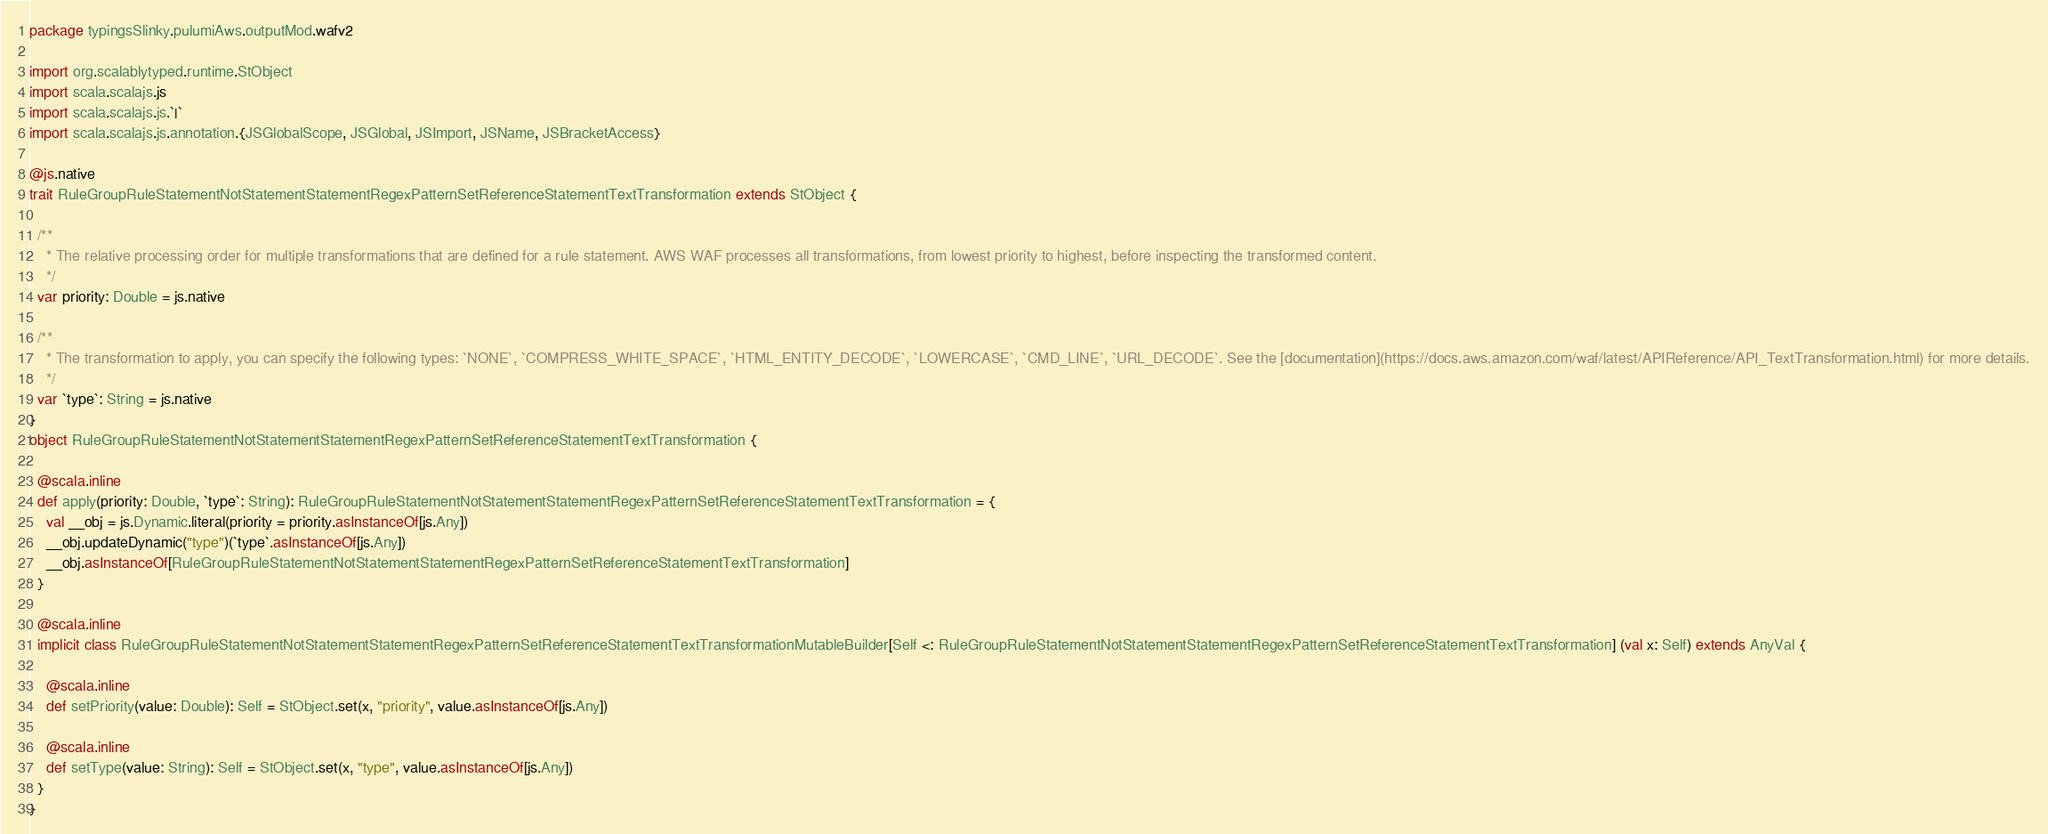Convert code to text. <code><loc_0><loc_0><loc_500><loc_500><_Scala_>package typingsSlinky.pulumiAws.outputMod.wafv2

import org.scalablytyped.runtime.StObject
import scala.scalajs.js
import scala.scalajs.js.`|`
import scala.scalajs.js.annotation.{JSGlobalScope, JSGlobal, JSImport, JSName, JSBracketAccess}

@js.native
trait RuleGroupRuleStatementNotStatementStatementRegexPatternSetReferenceStatementTextTransformation extends StObject {
  
  /**
    * The relative processing order for multiple transformations that are defined for a rule statement. AWS WAF processes all transformations, from lowest priority to highest, before inspecting the transformed content.
    */
  var priority: Double = js.native
  
  /**
    * The transformation to apply, you can specify the following types: `NONE`, `COMPRESS_WHITE_SPACE`, `HTML_ENTITY_DECODE`, `LOWERCASE`, `CMD_LINE`, `URL_DECODE`. See the [documentation](https://docs.aws.amazon.com/waf/latest/APIReference/API_TextTransformation.html) for more details.
    */
  var `type`: String = js.native
}
object RuleGroupRuleStatementNotStatementStatementRegexPatternSetReferenceStatementTextTransformation {
  
  @scala.inline
  def apply(priority: Double, `type`: String): RuleGroupRuleStatementNotStatementStatementRegexPatternSetReferenceStatementTextTransformation = {
    val __obj = js.Dynamic.literal(priority = priority.asInstanceOf[js.Any])
    __obj.updateDynamic("type")(`type`.asInstanceOf[js.Any])
    __obj.asInstanceOf[RuleGroupRuleStatementNotStatementStatementRegexPatternSetReferenceStatementTextTransformation]
  }
  
  @scala.inline
  implicit class RuleGroupRuleStatementNotStatementStatementRegexPatternSetReferenceStatementTextTransformationMutableBuilder[Self <: RuleGroupRuleStatementNotStatementStatementRegexPatternSetReferenceStatementTextTransformation] (val x: Self) extends AnyVal {
    
    @scala.inline
    def setPriority(value: Double): Self = StObject.set(x, "priority", value.asInstanceOf[js.Any])
    
    @scala.inline
    def setType(value: String): Self = StObject.set(x, "type", value.asInstanceOf[js.Any])
  }
}
</code> 